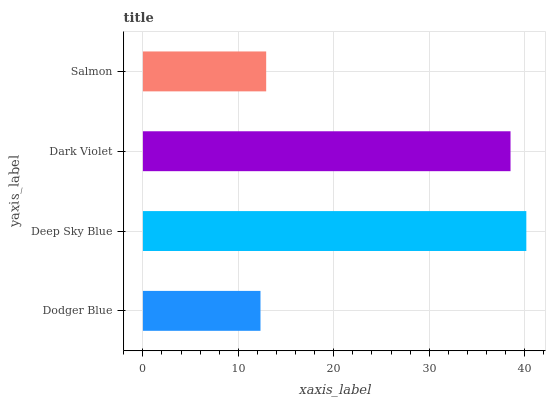Is Dodger Blue the minimum?
Answer yes or no. Yes. Is Deep Sky Blue the maximum?
Answer yes or no. Yes. Is Dark Violet the minimum?
Answer yes or no. No. Is Dark Violet the maximum?
Answer yes or no. No. Is Deep Sky Blue greater than Dark Violet?
Answer yes or no. Yes. Is Dark Violet less than Deep Sky Blue?
Answer yes or no. Yes. Is Dark Violet greater than Deep Sky Blue?
Answer yes or no. No. Is Deep Sky Blue less than Dark Violet?
Answer yes or no. No. Is Dark Violet the high median?
Answer yes or no. Yes. Is Salmon the low median?
Answer yes or no. Yes. Is Salmon the high median?
Answer yes or no. No. Is Dodger Blue the low median?
Answer yes or no. No. 